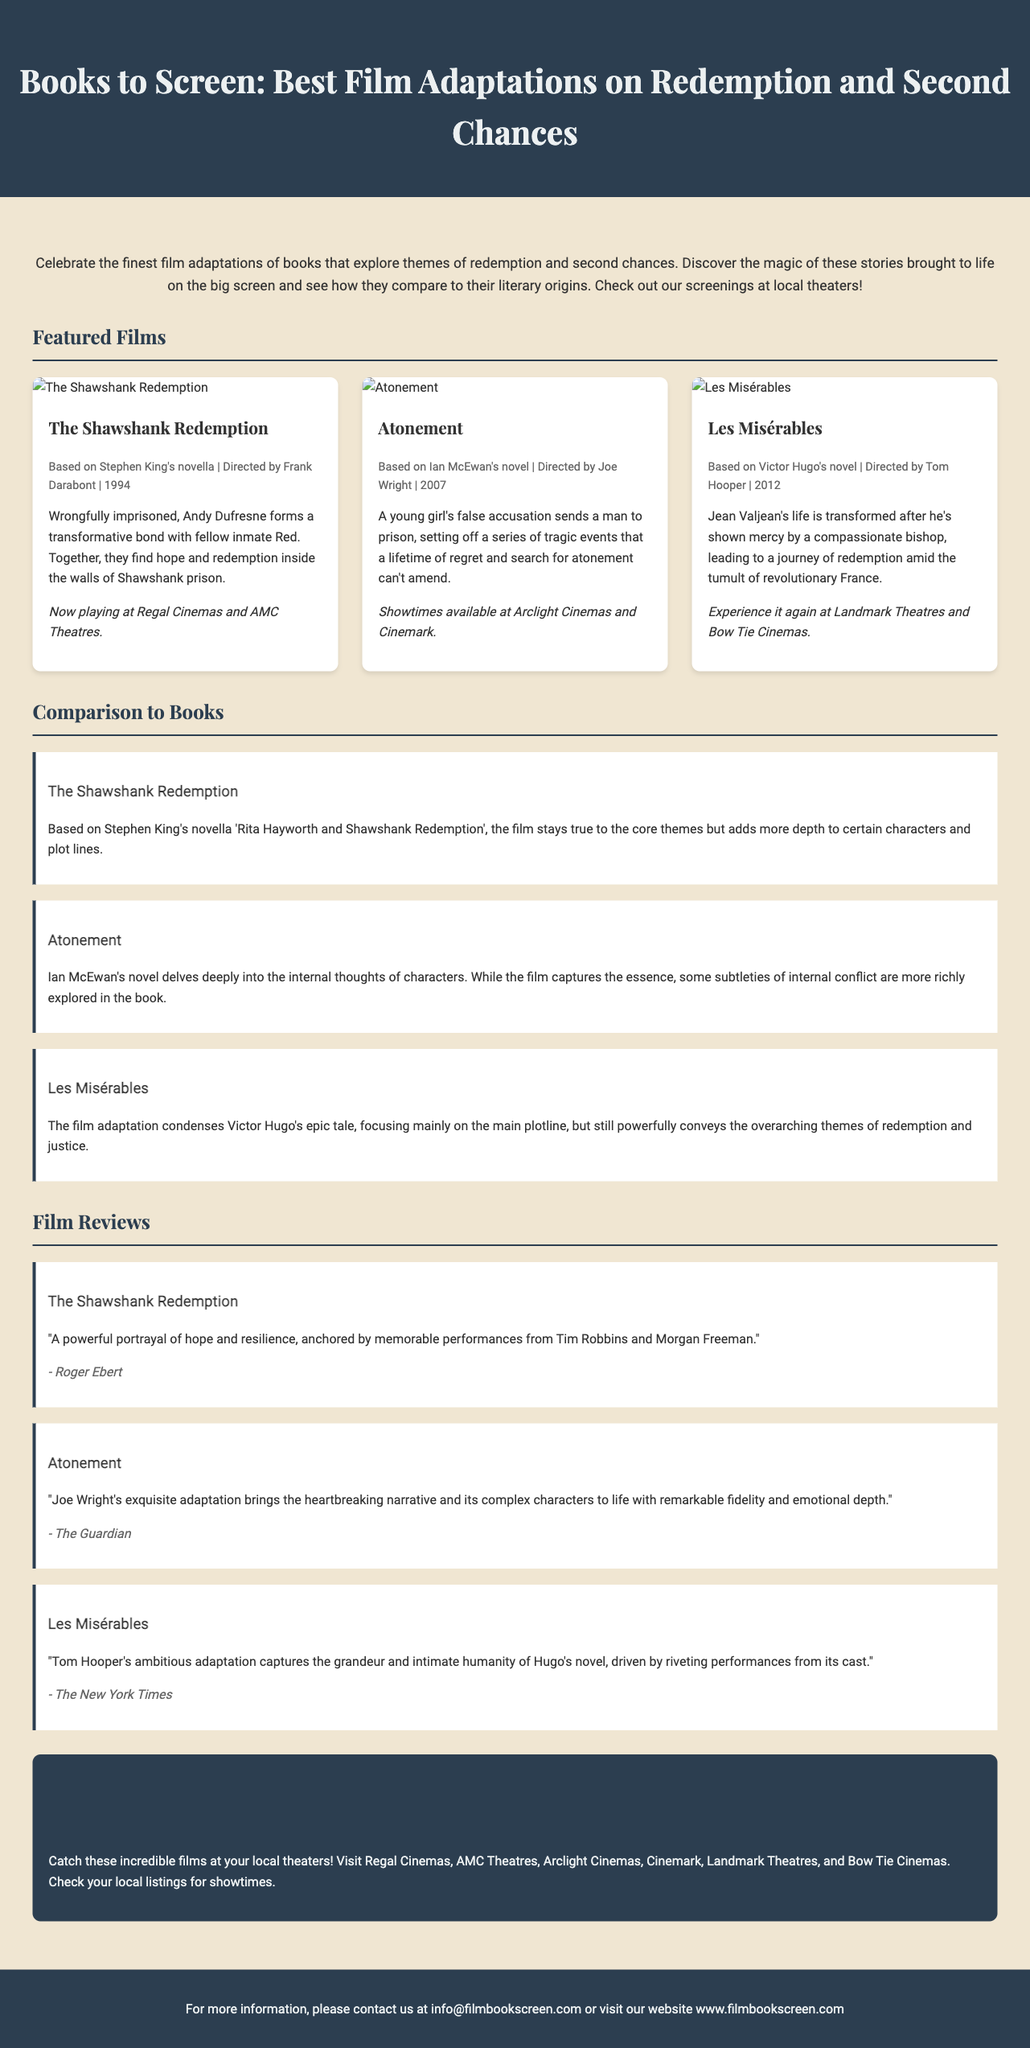What is the title of the event? The title is prominently displayed at the top of the flyer.
Answer: Books to Screen: Best Film Adaptations on Redemption and Second Chances How many featured films are listed in the document? The document specifically showcases three films under the Featured Films section.
Answer: 3 Which theater is screening "The Shawshank Redemption"? The information about where "The Shawshank Redemption" is playing is provided in the film details section.
Answer: Regal Cinemas and AMC Theatres Who directed "Atonement"? The director of "Atonement" is mentioned in the film details part of the film card.
Answer: Joe Wright What is the main theme explored in the featured films? The introductory paragraph highlights the central theme of the films being showcased.
Answer: Redemption and second chances What type of reviews are included for each film? The film reviews section contains quotes from notable sources providing feedback on the films.
Answer: Film reviews Which character's life is transformed by a bishop in "Les Misérables"? The film synopsis for "Les Misérables" mentions the character whose life changes due to the bishop's mercy.
Answer: Jean Valjean What is the source of the review for "The Shawshank Redemption"? Each review includes the reviewer's name or publication source at the end of the review.
Answer: Roger Ebert Where can audiences find showtimes? The document specifies where to find information about screening times.
Answer: Local listings 